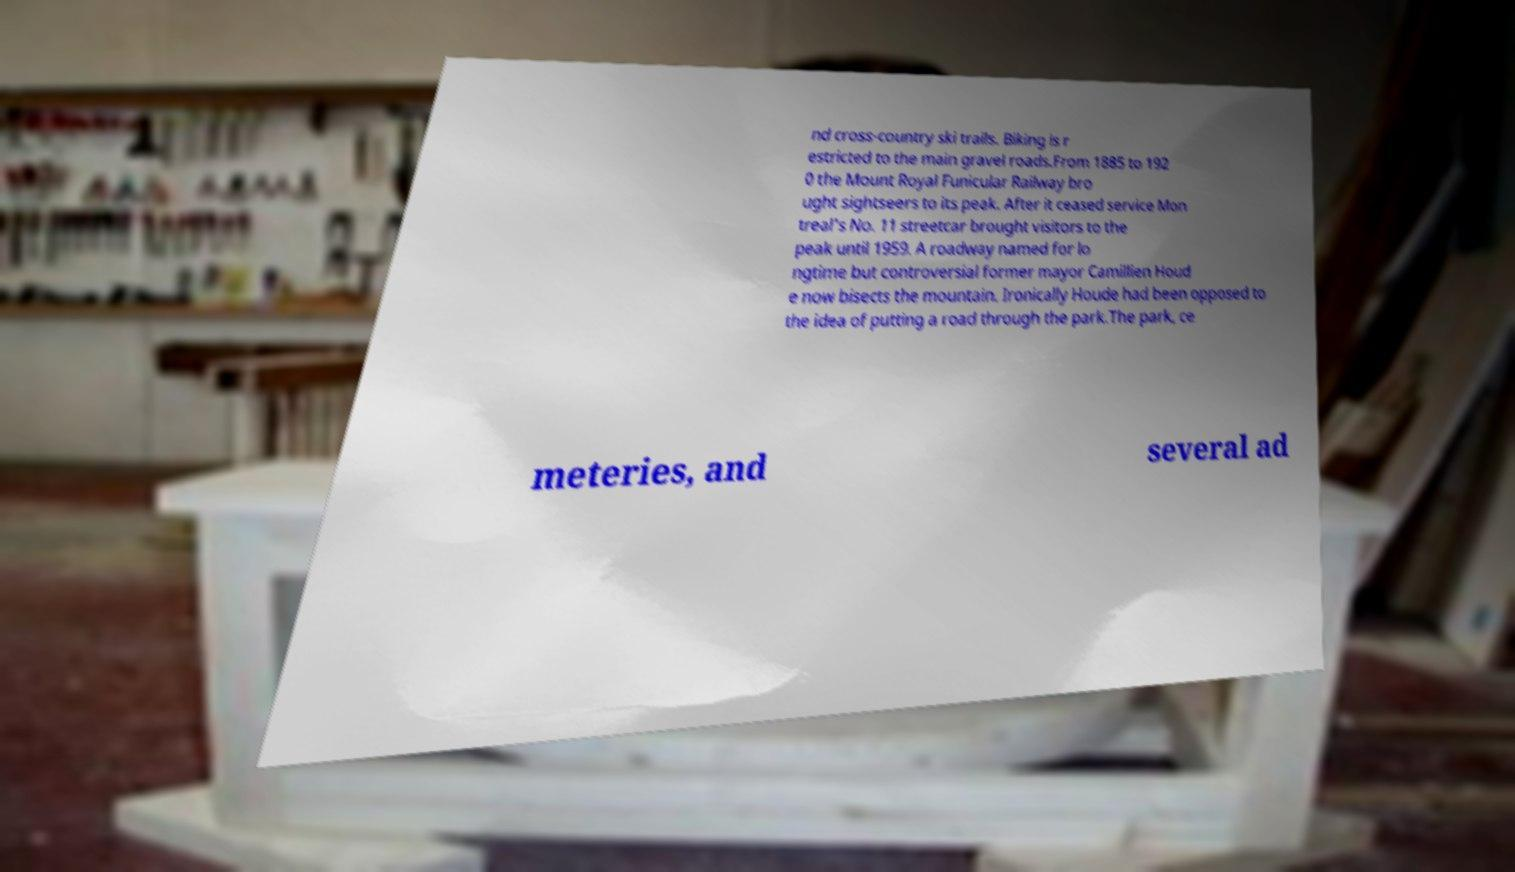Please read and relay the text visible in this image. What does it say? nd cross-country ski trails. Biking is r estricted to the main gravel roads.From 1885 to 192 0 the Mount Royal Funicular Railway bro ught sightseers to its peak. After it ceased service Mon treal's No. 11 streetcar brought visitors to the peak until 1959. A roadway named for lo ngtime but controversial former mayor Camillien Houd e now bisects the mountain. Ironically Houde had been opposed to the idea of putting a road through the park.The park, ce meteries, and several ad 